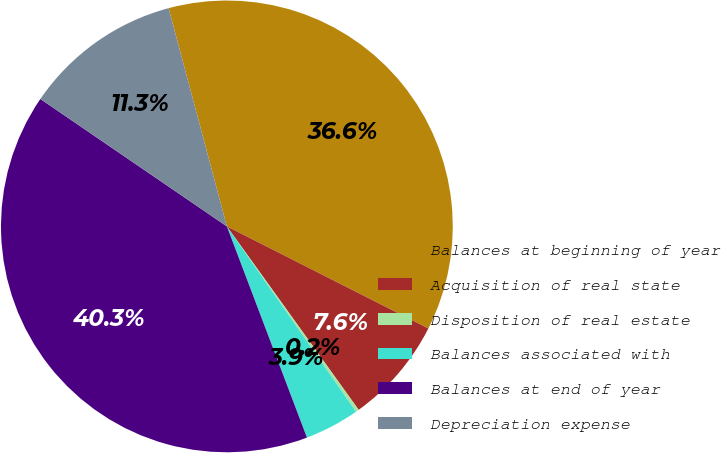<chart> <loc_0><loc_0><loc_500><loc_500><pie_chart><fcel>Balances at beginning of year<fcel>Acquisition of real state<fcel>Disposition of real estate<fcel>Balances associated with<fcel>Balances at end of year<fcel>Depreciation expense<nl><fcel>36.62%<fcel>7.62%<fcel>0.23%<fcel>3.92%<fcel>40.31%<fcel>11.31%<nl></chart> 